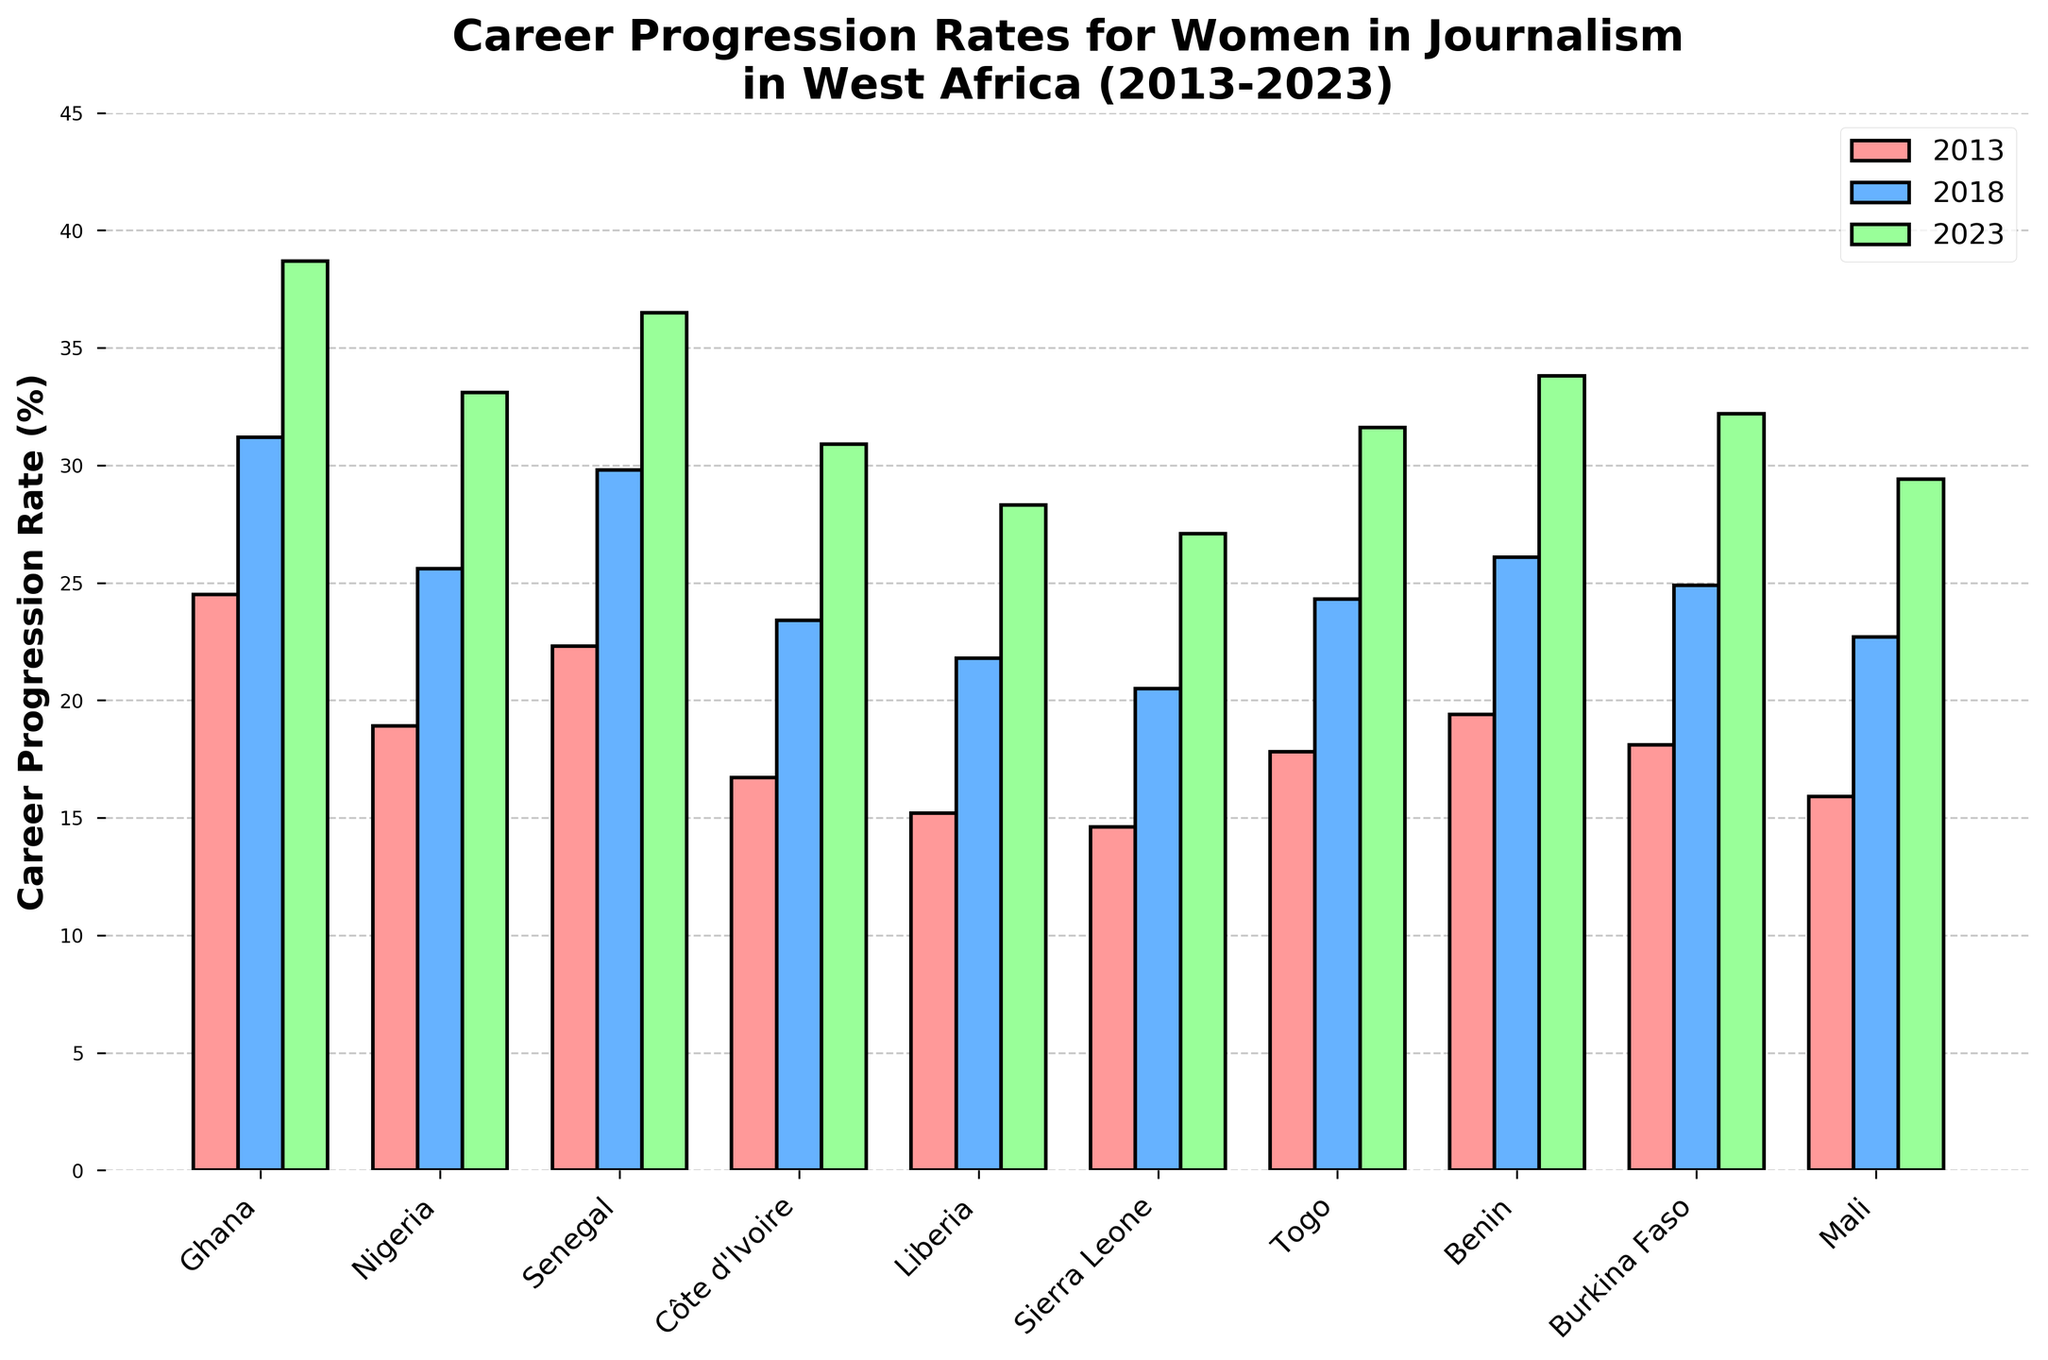What is the career progression rate for women in journalism in Nigeria in 2013 compared to 2023? Look at the bar heights for Nigeria in the year 2013 and 2023. The bar on the left (2013) indicates the value for that year, while the bar on the right (2023) represents the value for that year. Nigeria's rates are 18.9% in 2013 and 33.1% in 2023.
Answer: Nigeria's career progression rate in 2013 is 18.9% and in 2023 is 33.1% How does the career progression rate for women in journalism in Ghana change from 2013 to 2023? Identify the bar heights for Ghana across the different years, particularly 2013 and 2023. The value for 2013 is 24.5%, and for 2023 is 38.7%. The change is calculated by finding the difference between these values: 38.7 - 24.5 = 14.2%.
Answer: The rate increased by 14.2% Which country shows the greatest overall growth in career progression rates for women in journalism from 2013 to 2023? Calculate the difference in rates between 2013 and 2023 for each country and compare them. The greatest difference will indicate the highest growth. For example, for Ghana: 38.7 - 24.5 = 14.2%. Repeat for all countries and find the maximum value.
Answer: Ghana with an increase of 14.2% Among the countries listed, which one had the least career progression rate for women in journalism in 2013? Compare the heights of the bars for the year 2013 across all countries. The shortest bar indicates the smallest value. Liberia's bar is the shortest for 2013, indicating 15.2%.
Answer: Liberia with 15.2% Which two countries have shown similar career progression rates for women in journalism in 2023? Look at the bar heights for 2023 for all countries and identify pairs that have similar heights and rates. Benin and Nigeria have similar heights in 2023, both around 33.8% and 33.1%.
Answer: Benin and Nigeria What is the average career progression rate for women in journalism in 2023 across all listed countries? Sum up the career progression rates for 2023 for all countries and divide by the number of countries (10). The rates are: 38.7, 33.1, 36.5, 30.9, 28.3, 27.1, 31.6, 33.8, 32.2, 29.4. Adding these gives 321.6, and dividing by 10 gives 32.16.
Answer: 32.16% In which year do Burkina Faso and Togo have an almost equal career progression rate for women in journalism? Compare the heights of bars for Burkina Faso and Togo across the three years. In 2018, both Burkina Faso (24.9%) and Togo (24.3%) have nearly equal rates.
Answer: 2018 By how much did the career progression rate for women in journalism increase in Côte d'Ivoire from 2013 to 2018? Check the rates for Côte d'Ivoire in 2013 (16.7%) and 2018 (23.4%). The increase is found by subtracting the 2013 rate from the 2018 rate: 23.4 - 16.7 = 6.7%.
Answer: 6.7% Which country had the highest career progression rate for women in journalism in 2023? Identify the tallest bar in 2023. Ghana's bar is the tallest in that year, indicating a rate of 38.7%.
Answer: Ghana with 38.7% 